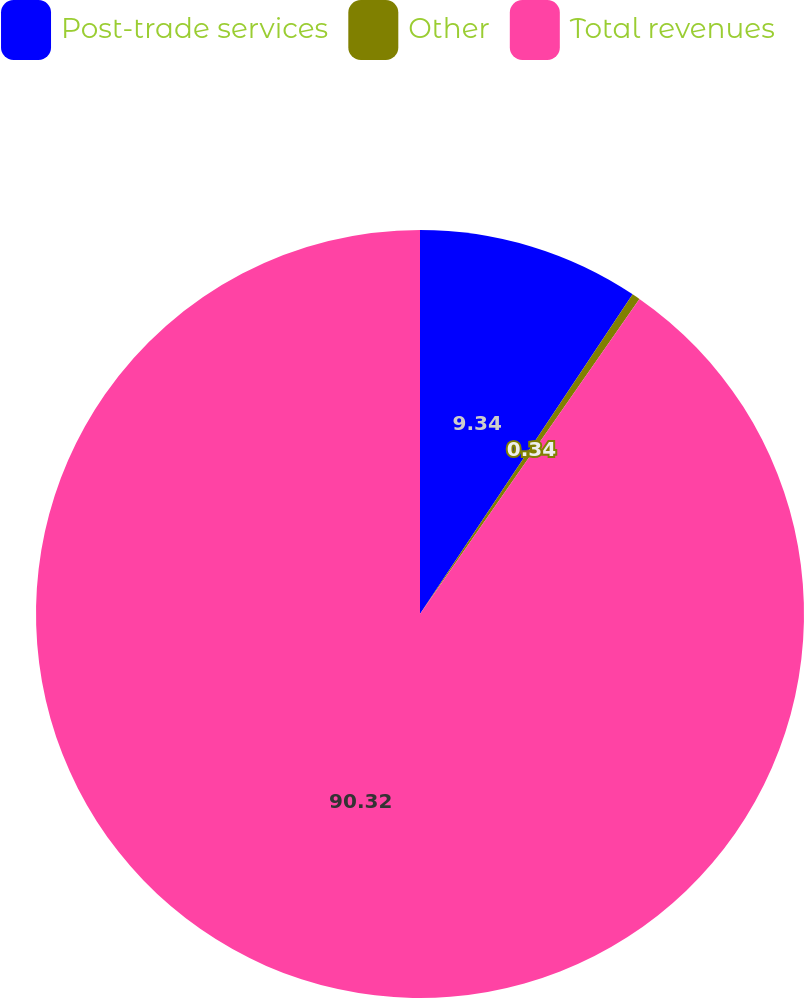<chart> <loc_0><loc_0><loc_500><loc_500><pie_chart><fcel>Post-trade services<fcel>Other<fcel>Total revenues<nl><fcel>9.34%<fcel>0.34%<fcel>90.31%<nl></chart> 